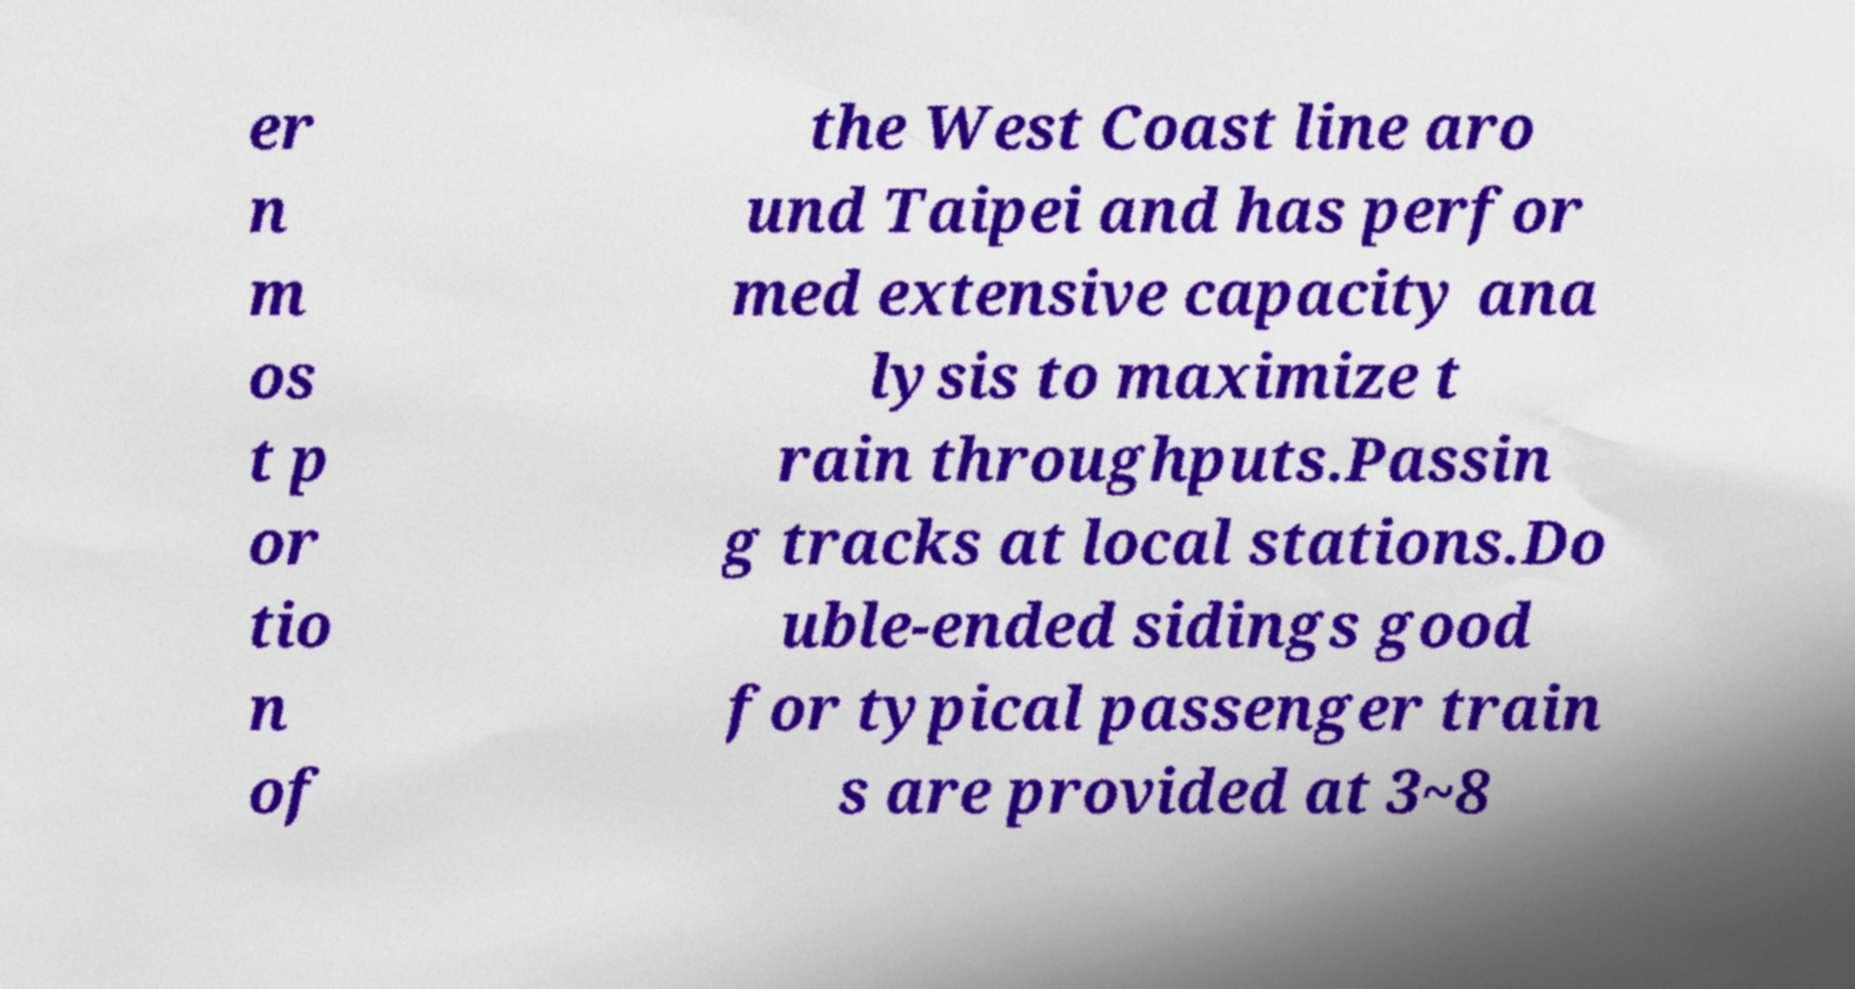Could you extract and type out the text from this image? er n m os t p or tio n of the West Coast line aro und Taipei and has perfor med extensive capacity ana lysis to maximize t rain throughputs.Passin g tracks at local stations.Do uble-ended sidings good for typical passenger train s are provided at 3~8 